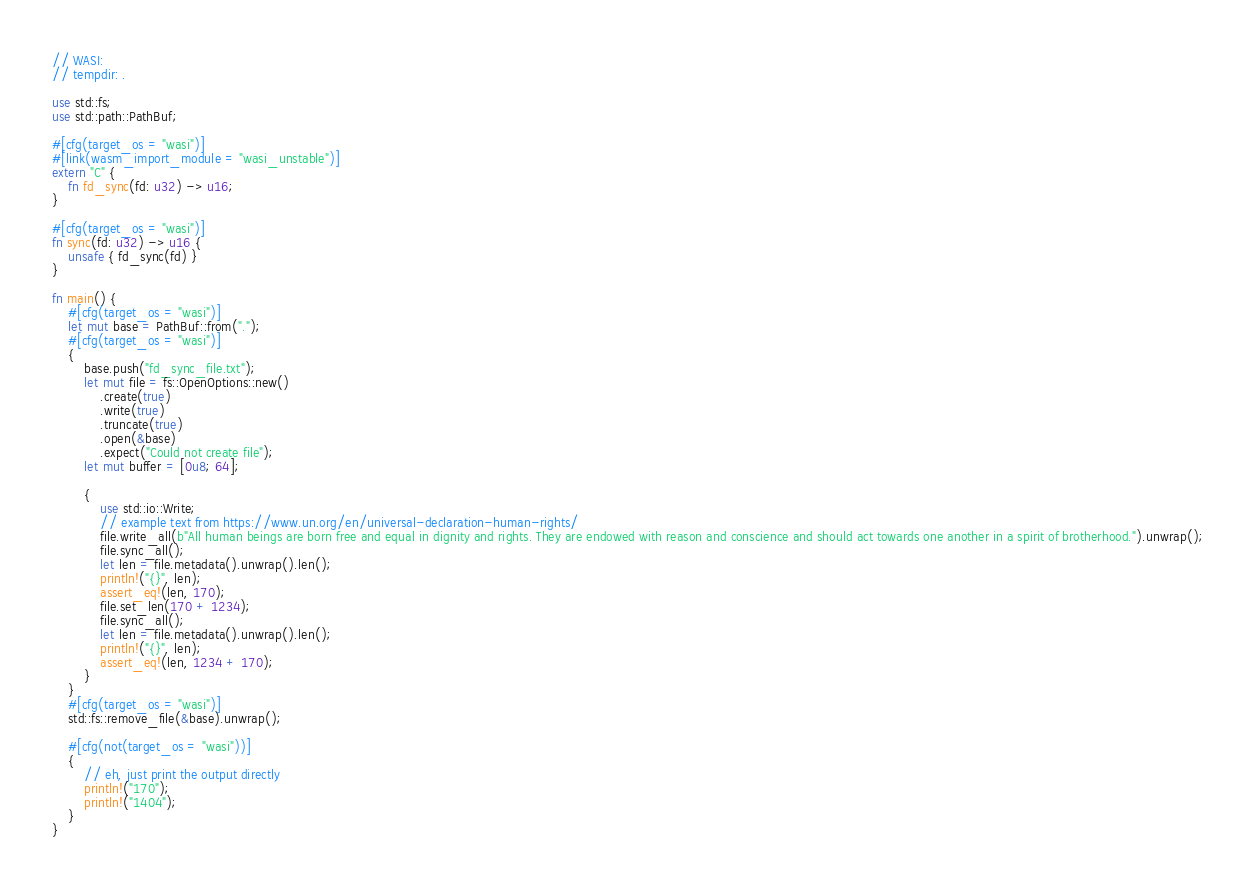Convert code to text. <code><loc_0><loc_0><loc_500><loc_500><_Rust_>// WASI:
// tempdir: .

use std::fs;
use std::path::PathBuf;

#[cfg(target_os = "wasi")]
#[link(wasm_import_module = "wasi_unstable")]
extern "C" {
    fn fd_sync(fd: u32) -> u16;
}

#[cfg(target_os = "wasi")]
fn sync(fd: u32) -> u16 {
    unsafe { fd_sync(fd) }
}

fn main() {
    #[cfg(target_os = "wasi")]
    let mut base = PathBuf::from(".");
    #[cfg(target_os = "wasi")]
    {
        base.push("fd_sync_file.txt");
        let mut file = fs::OpenOptions::new()
            .create(true)
            .write(true)
            .truncate(true)
            .open(&base)
            .expect("Could not create file");
        let mut buffer = [0u8; 64];

        {
            use std::io::Write;
            // example text from https://www.un.org/en/universal-declaration-human-rights/
            file.write_all(b"All human beings are born free and equal in dignity and rights. They are endowed with reason and conscience and should act towards one another in a spirit of brotherhood.").unwrap();
            file.sync_all();
            let len = file.metadata().unwrap().len();
            println!("{}", len);
            assert_eq!(len, 170);
            file.set_len(170 + 1234);
            file.sync_all();
            let len = file.metadata().unwrap().len();
            println!("{}", len);
            assert_eq!(len, 1234 + 170);
        }
    }
    #[cfg(target_os = "wasi")]
    std::fs::remove_file(&base).unwrap();

    #[cfg(not(target_os = "wasi"))]
    {
        // eh, just print the output directly
        println!("170");
        println!("1404");
    }
}
</code> 